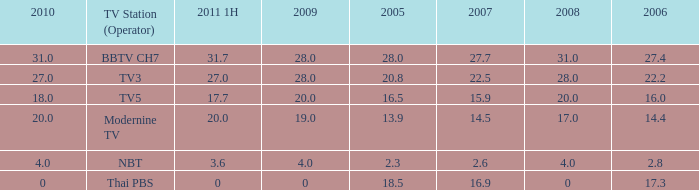What is the highest 2011 1H value for a 2005 over 28? None. 